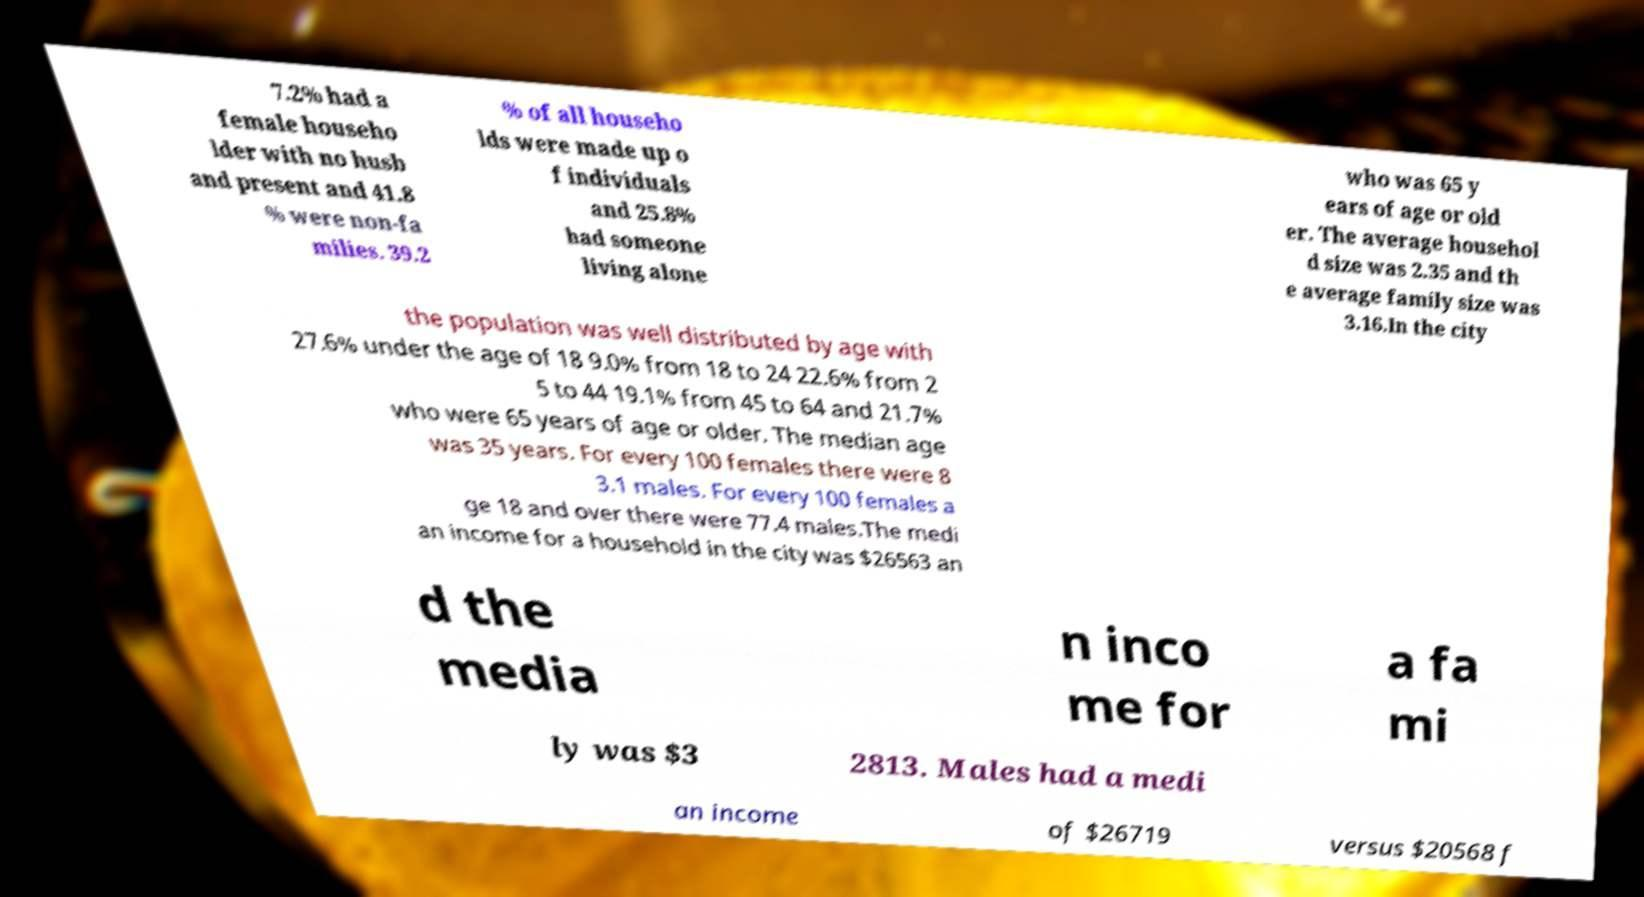Please read and relay the text visible in this image. What does it say? 7.2% had a female househo lder with no husb and present and 41.8 % were non-fa milies. 39.2 % of all househo lds were made up o f individuals and 25.8% had someone living alone who was 65 y ears of age or old er. The average househol d size was 2.35 and th e average family size was 3.16.In the city the population was well distributed by age with 27.6% under the age of 18 9.0% from 18 to 24 22.6% from 2 5 to 44 19.1% from 45 to 64 and 21.7% who were 65 years of age or older. The median age was 35 years. For every 100 females there were 8 3.1 males. For every 100 females a ge 18 and over there were 77.4 males.The medi an income for a household in the city was $26563 an d the media n inco me for a fa mi ly was $3 2813. Males had a medi an income of $26719 versus $20568 f 